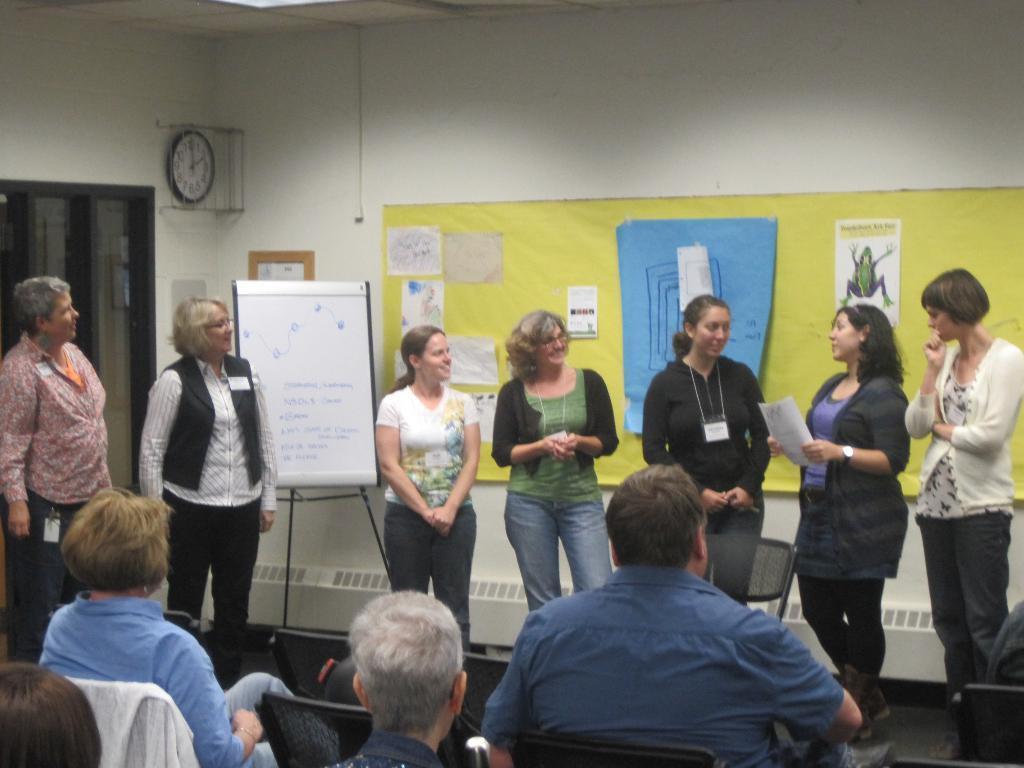How would you summarize this image in a sentence or two? In this image I can see a group of ladies are standing and speaking, behind them there are papers stick to the board. At the bottom few people are sitting on the chairs and looking at them. On the left side there is a wall clock. 